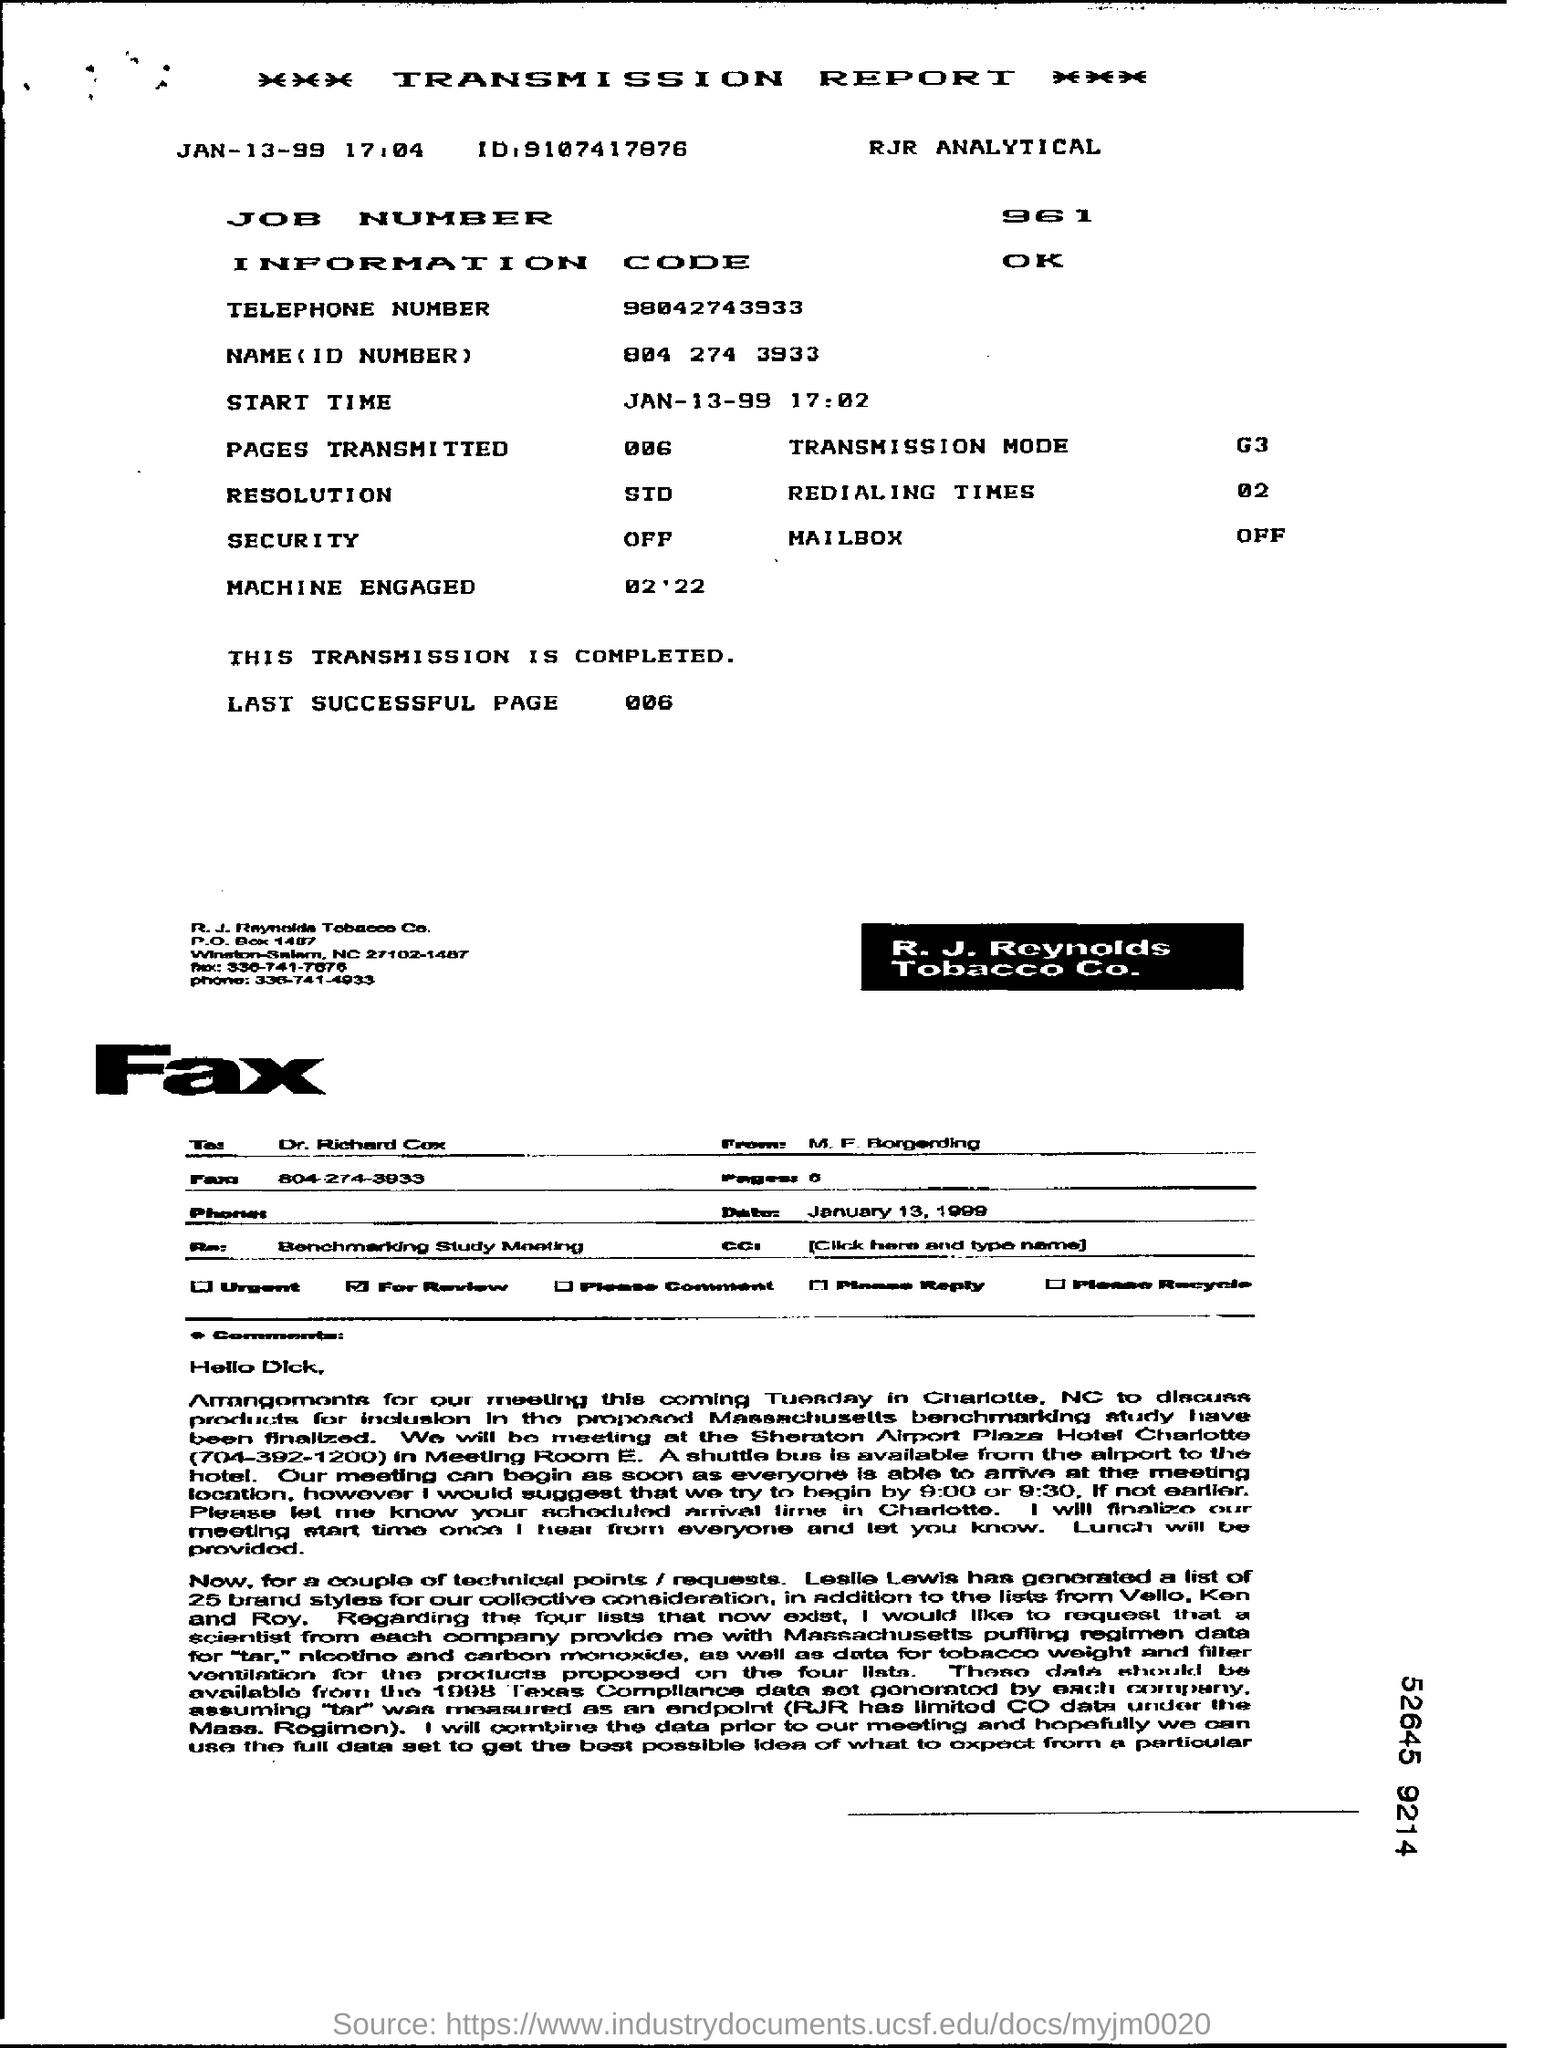What is the JOB Number ?
Provide a succinct answer. 961. What is the Information Code ?
Your answer should be very brief. OK. What date mentioned in the top left of the document ?
Your response must be concise. Jan-13-99. What is the Telephone Number ?
Your response must be concise. 98042743933. What is written in the Transmission Mode Field ?
Give a very brief answer. G3. What is written in the Mailbox Field ?
Keep it short and to the point. Off. 